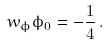Convert formula to latex. <formula><loc_0><loc_0><loc_500><loc_500>w _ { \phi } \phi _ { 0 } = - \frac { 1 } { 4 } \, .</formula> 